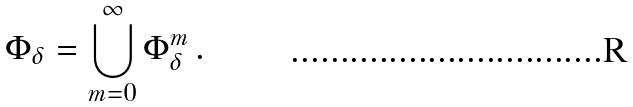<formula> <loc_0><loc_0><loc_500><loc_500>\Phi _ { \delta } = \bigcup _ { m = 0 } ^ { \infty } \Phi _ { \delta } ^ { m } \, .</formula> 